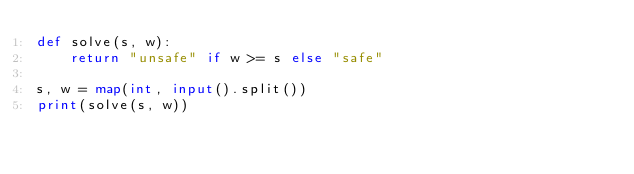Convert code to text. <code><loc_0><loc_0><loc_500><loc_500><_Python_>def solve(s, w):
    return "unsafe" if w >= s else "safe"

s, w = map(int, input().split())
print(solve(s, w))
</code> 